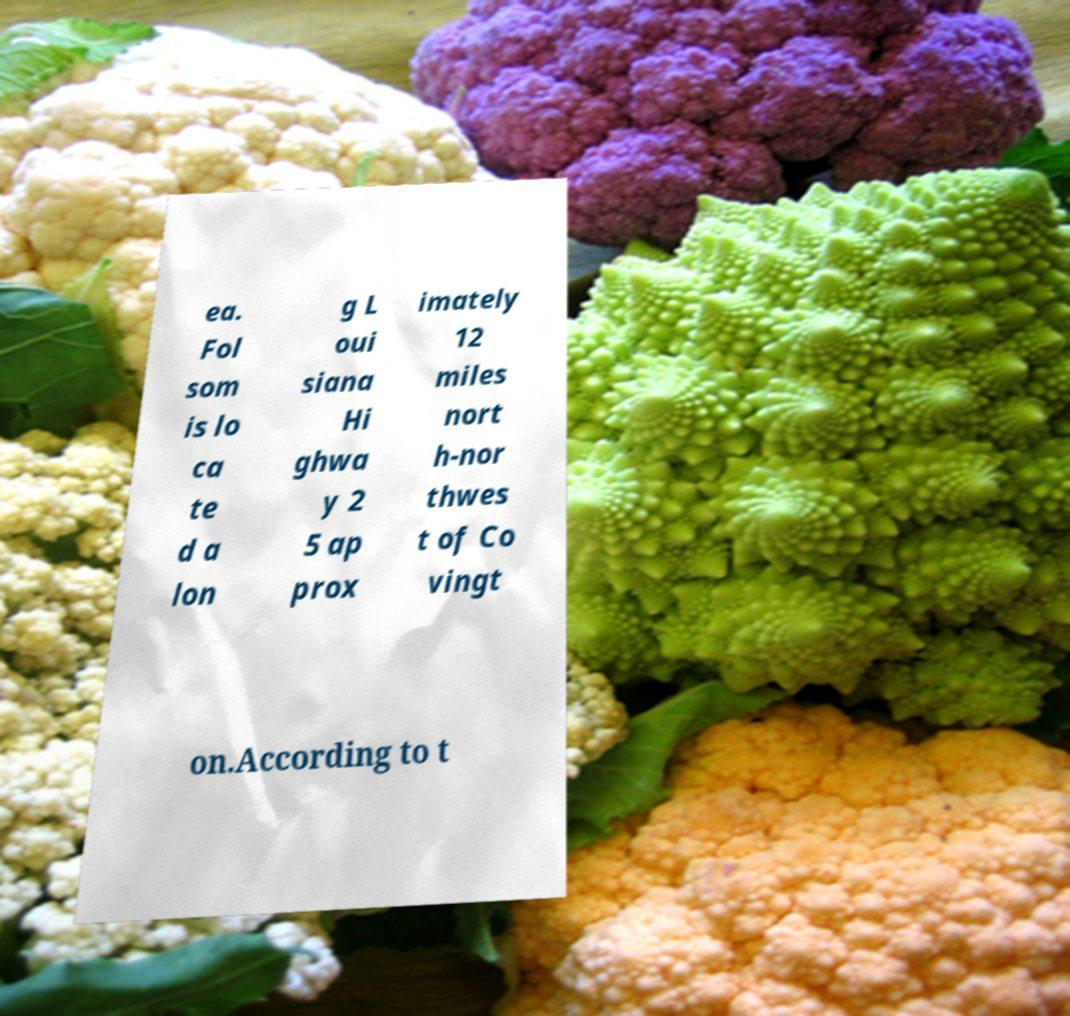I need the written content from this picture converted into text. Can you do that? ea. Fol som is lo ca te d a lon g L oui siana Hi ghwa y 2 5 ap prox imately 12 miles nort h-nor thwes t of Co vingt on.According to t 